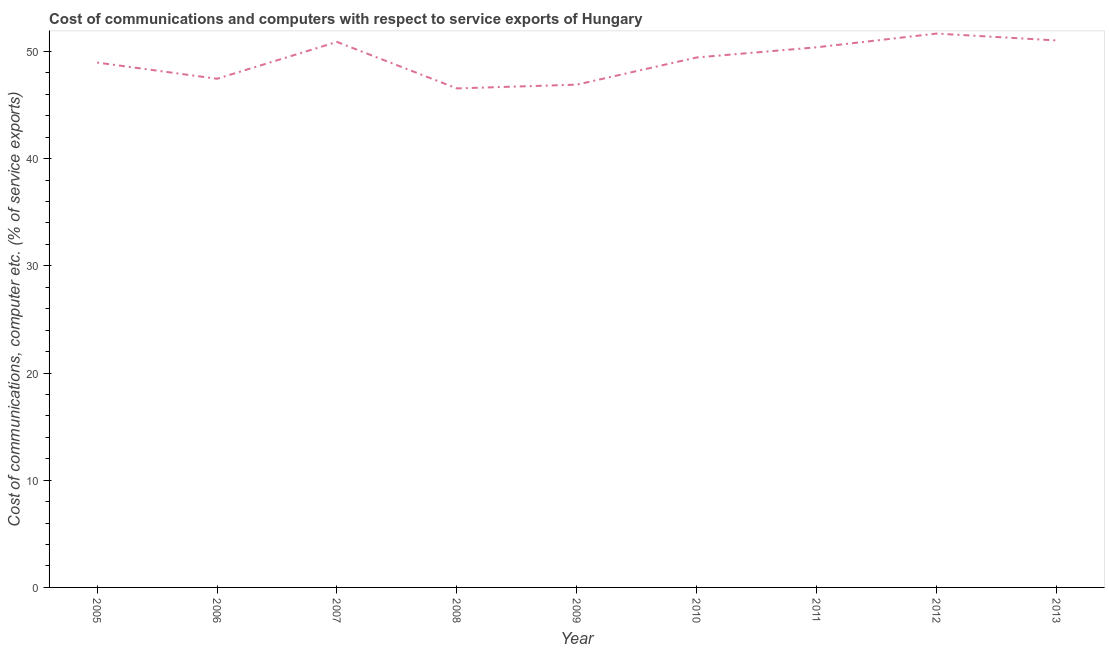What is the cost of communications and computer in 2005?
Offer a very short reply. 48.97. Across all years, what is the maximum cost of communications and computer?
Give a very brief answer. 51.67. Across all years, what is the minimum cost of communications and computer?
Offer a very short reply. 46.55. In which year was the cost of communications and computer minimum?
Give a very brief answer. 2008. What is the sum of the cost of communications and computer?
Your response must be concise. 443.29. What is the difference between the cost of communications and computer in 2006 and 2013?
Your answer should be compact. -3.57. What is the average cost of communications and computer per year?
Provide a succinct answer. 49.25. What is the median cost of communications and computer?
Make the answer very short. 49.44. In how many years, is the cost of communications and computer greater than 28 %?
Offer a very short reply. 9. What is the ratio of the cost of communications and computer in 2009 to that in 2010?
Your answer should be compact. 0.95. Is the cost of communications and computer in 2007 less than that in 2009?
Provide a succinct answer. No. What is the difference between the highest and the second highest cost of communications and computer?
Give a very brief answer. 0.64. Is the sum of the cost of communications and computer in 2008 and 2009 greater than the maximum cost of communications and computer across all years?
Offer a terse response. Yes. What is the difference between the highest and the lowest cost of communications and computer?
Provide a succinct answer. 5.12. Does the cost of communications and computer monotonically increase over the years?
Offer a very short reply. No. How many lines are there?
Offer a very short reply. 1. Does the graph contain grids?
Make the answer very short. No. What is the title of the graph?
Your answer should be compact. Cost of communications and computers with respect to service exports of Hungary. What is the label or title of the Y-axis?
Give a very brief answer. Cost of communications, computer etc. (% of service exports). What is the Cost of communications, computer etc. (% of service exports) of 2005?
Your answer should be very brief. 48.97. What is the Cost of communications, computer etc. (% of service exports) in 2006?
Ensure brevity in your answer.  47.45. What is the Cost of communications, computer etc. (% of service exports) of 2007?
Make the answer very short. 50.89. What is the Cost of communications, computer etc. (% of service exports) of 2008?
Make the answer very short. 46.55. What is the Cost of communications, computer etc. (% of service exports) in 2009?
Offer a terse response. 46.9. What is the Cost of communications, computer etc. (% of service exports) in 2010?
Provide a succinct answer. 49.44. What is the Cost of communications, computer etc. (% of service exports) in 2011?
Provide a short and direct response. 50.39. What is the Cost of communications, computer etc. (% of service exports) of 2012?
Ensure brevity in your answer.  51.67. What is the Cost of communications, computer etc. (% of service exports) of 2013?
Offer a very short reply. 51.03. What is the difference between the Cost of communications, computer etc. (% of service exports) in 2005 and 2006?
Make the answer very short. 1.51. What is the difference between the Cost of communications, computer etc. (% of service exports) in 2005 and 2007?
Keep it short and to the point. -1.92. What is the difference between the Cost of communications, computer etc. (% of service exports) in 2005 and 2008?
Provide a succinct answer. 2.41. What is the difference between the Cost of communications, computer etc. (% of service exports) in 2005 and 2009?
Provide a succinct answer. 2.06. What is the difference between the Cost of communications, computer etc. (% of service exports) in 2005 and 2010?
Provide a succinct answer. -0.47. What is the difference between the Cost of communications, computer etc. (% of service exports) in 2005 and 2011?
Provide a succinct answer. -1.42. What is the difference between the Cost of communications, computer etc. (% of service exports) in 2005 and 2012?
Keep it short and to the point. -2.7. What is the difference between the Cost of communications, computer etc. (% of service exports) in 2005 and 2013?
Keep it short and to the point. -2.06. What is the difference between the Cost of communications, computer etc. (% of service exports) in 2006 and 2007?
Provide a succinct answer. -3.44. What is the difference between the Cost of communications, computer etc. (% of service exports) in 2006 and 2008?
Keep it short and to the point. 0.9. What is the difference between the Cost of communications, computer etc. (% of service exports) in 2006 and 2009?
Provide a short and direct response. 0.55. What is the difference between the Cost of communications, computer etc. (% of service exports) in 2006 and 2010?
Offer a very short reply. -1.99. What is the difference between the Cost of communications, computer etc. (% of service exports) in 2006 and 2011?
Make the answer very short. -2.93. What is the difference between the Cost of communications, computer etc. (% of service exports) in 2006 and 2012?
Your response must be concise. -4.22. What is the difference between the Cost of communications, computer etc. (% of service exports) in 2006 and 2013?
Give a very brief answer. -3.57. What is the difference between the Cost of communications, computer etc. (% of service exports) in 2007 and 2008?
Offer a very short reply. 4.34. What is the difference between the Cost of communications, computer etc. (% of service exports) in 2007 and 2009?
Provide a succinct answer. 3.99. What is the difference between the Cost of communications, computer etc. (% of service exports) in 2007 and 2010?
Offer a terse response. 1.45. What is the difference between the Cost of communications, computer etc. (% of service exports) in 2007 and 2011?
Offer a very short reply. 0.5. What is the difference between the Cost of communications, computer etc. (% of service exports) in 2007 and 2012?
Provide a succinct answer. -0.78. What is the difference between the Cost of communications, computer etc. (% of service exports) in 2007 and 2013?
Give a very brief answer. -0.14. What is the difference between the Cost of communications, computer etc. (% of service exports) in 2008 and 2009?
Your answer should be compact. -0.35. What is the difference between the Cost of communications, computer etc. (% of service exports) in 2008 and 2010?
Give a very brief answer. -2.89. What is the difference between the Cost of communications, computer etc. (% of service exports) in 2008 and 2011?
Provide a short and direct response. -3.84. What is the difference between the Cost of communications, computer etc. (% of service exports) in 2008 and 2012?
Offer a very short reply. -5.12. What is the difference between the Cost of communications, computer etc. (% of service exports) in 2008 and 2013?
Offer a terse response. -4.47. What is the difference between the Cost of communications, computer etc. (% of service exports) in 2009 and 2010?
Make the answer very short. -2.54. What is the difference between the Cost of communications, computer etc. (% of service exports) in 2009 and 2011?
Your response must be concise. -3.48. What is the difference between the Cost of communications, computer etc. (% of service exports) in 2009 and 2012?
Offer a very short reply. -4.76. What is the difference between the Cost of communications, computer etc. (% of service exports) in 2009 and 2013?
Provide a succinct answer. -4.12. What is the difference between the Cost of communications, computer etc. (% of service exports) in 2010 and 2011?
Your answer should be very brief. -0.95. What is the difference between the Cost of communications, computer etc. (% of service exports) in 2010 and 2012?
Make the answer very short. -2.23. What is the difference between the Cost of communications, computer etc. (% of service exports) in 2010 and 2013?
Provide a short and direct response. -1.59. What is the difference between the Cost of communications, computer etc. (% of service exports) in 2011 and 2012?
Keep it short and to the point. -1.28. What is the difference between the Cost of communications, computer etc. (% of service exports) in 2011 and 2013?
Offer a very short reply. -0.64. What is the difference between the Cost of communications, computer etc. (% of service exports) in 2012 and 2013?
Offer a terse response. 0.64. What is the ratio of the Cost of communications, computer etc. (% of service exports) in 2005 to that in 2006?
Ensure brevity in your answer.  1.03. What is the ratio of the Cost of communications, computer etc. (% of service exports) in 2005 to that in 2008?
Offer a very short reply. 1.05. What is the ratio of the Cost of communications, computer etc. (% of service exports) in 2005 to that in 2009?
Provide a succinct answer. 1.04. What is the ratio of the Cost of communications, computer etc. (% of service exports) in 2005 to that in 2012?
Your response must be concise. 0.95. What is the ratio of the Cost of communications, computer etc. (% of service exports) in 2006 to that in 2007?
Provide a succinct answer. 0.93. What is the ratio of the Cost of communications, computer etc. (% of service exports) in 2006 to that in 2009?
Provide a succinct answer. 1.01. What is the ratio of the Cost of communications, computer etc. (% of service exports) in 2006 to that in 2010?
Offer a terse response. 0.96. What is the ratio of the Cost of communications, computer etc. (% of service exports) in 2006 to that in 2011?
Provide a succinct answer. 0.94. What is the ratio of the Cost of communications, computer etc. (% of service exports) in 2006 to that in 2012?
Your answer should be compact. 0.92. What is the ratio of the Cost of communications, computer etc. (% of service exports) in 2007 to that in 2008?
Your answer should be very brief. 1.09. What is the ratio of the Cost of communications, computer etc. (% of service exports) in 2007 to that in 2009?
Provide a succinct answer. 1.08. What is the ratio of the Cost of communications, computer etc. (% of service exports) in 2007 to that in 2010?
Your response must be concise. 1.03. What is the ratio of the Cost of communications, computer etc. (% of service exports) in 2007 to that in 2011?
Offer a very short reply. 1.01. What is the ratio of the Cost of communications, computer etc. (% of service exports) in 2007 to that in 2012?
Give a very brief answer. 0.98. What is the ratio of the Cost of communications, computer etc. (% of service exports) in 2008 to that in 2009?
Keep it short and to the point. 0.99. What is the ratio of the Cost of communications, computer etc. (% of service exports) in 2008 to that in 2010?
Offer a very short reply. 0.94. What is the ratio of the Cost of communications, computer etc. (% of service exports) in 2008 to that in 2011?
Your response must be concise. 0.92. What is the ratio of the Cost of communications, computer etc. (% of service exports) in 2008 to that in 2012?
Give a very brief answer. 0.9. What is the ratio of the Cost of communications, computer etc. (% of service exports) in 2008 to that in 2013?
Keep it short and to the point. 0.91. What is the ratio of the Cost of communications, computer etc. (% of service exports) in 2009 to that in 2010?
Offer a very short reply. 0.95. What is the ratio of the Cost of communications, computer etc. (% of service exports) in 2009 to that in 2011?
Your answer should be compact. 0.93. What is the ratio of the Cost of communications, computer etc. (% of service exports) in 2009 to that in 2012?
Offer a very short reply. 0.91. What is the ratio of the Cost of communications, computer etc. (% of service exports) in 2009 to that in 2013?
Your answer should be very brief. 0.92. What is the ratio of the Cost of communications, computer etc. (% of service exports) in 2010 to that in 2011?
Ensure brevity in your answer.  0.98. What is the ratio of the Cost of communications, computer etc. (% of service exports) in 2010 to that in 2012?
Keep it short and to the point. 0.96. What is the ratio of the Cost of communications, computer etc. (% of service exports) in 2011 to that in 2012?
Give a very brief answer. 0.97. What is the ratio of the Cost of communications, computer etc. (% of service exports) in 2012 to that in 2013?
Keep it short and to the point. 1.01. 